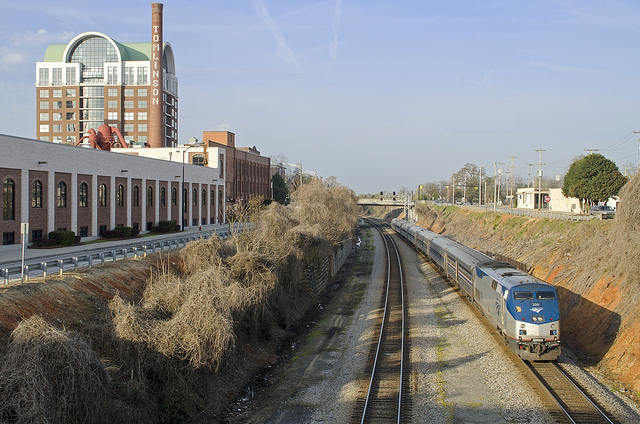Identify the text contained in this image. TOMLINSON 